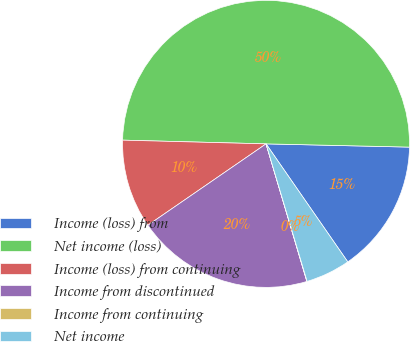<chart> <loc_0><loc_0><loc_500><loc_500><pie_chart><fcel>Income (loss) from<fcel>Net income (loss)<fcel>Income (loss) from continuing<fcel>Income from discontinued<fcel>Income from continuing<fcel>Net income<nl><fcel>15.0%<fcel>49.94%<fcel>10.01%<fcel>19.99%<fcel>0.03%<fcel>5.02%<nl></chart> 